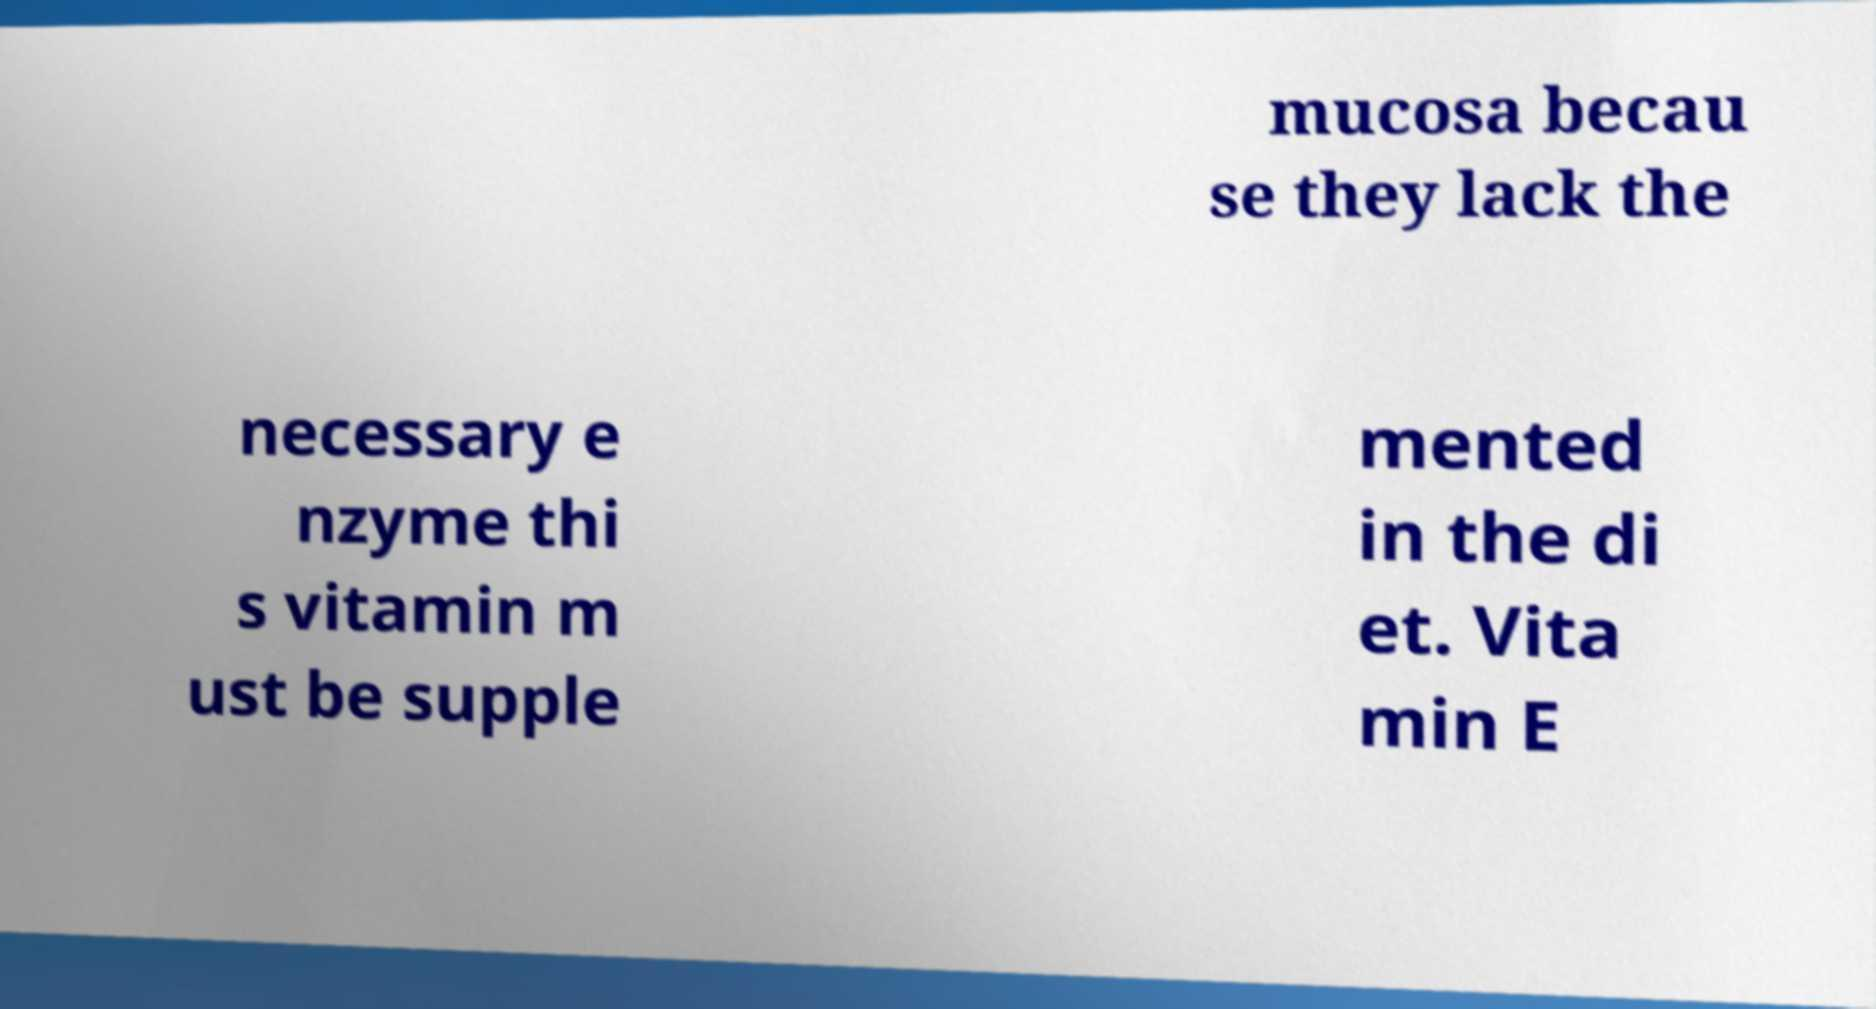What messages or text are displayed in this image? I need them in a readable, typed format. mucosa becau se they lack the necessary e nzyme thi s vitamin m ust be supple mented in the di et. Vita min E 